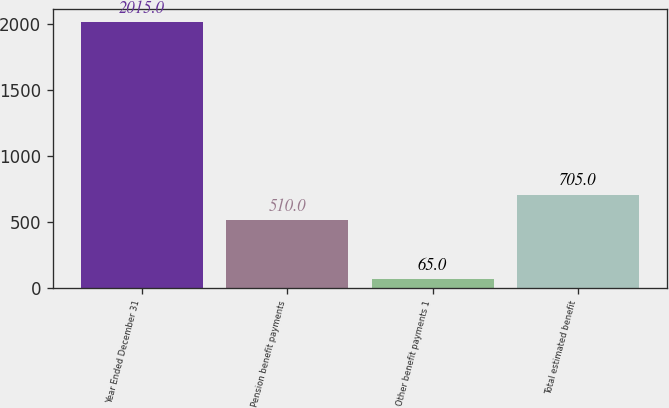Convert chart. <chart><loc_0><loc_0><loc_500><loc_500><bar_chart><fcel>Year Ended December 31<fcel>Pension benefit payments<fcel>Other benefit payments 1<fcel>Total estimated benefit<nl><fcel>2015<fcel>510<fcel>65<fcel>705<nl></chart> 